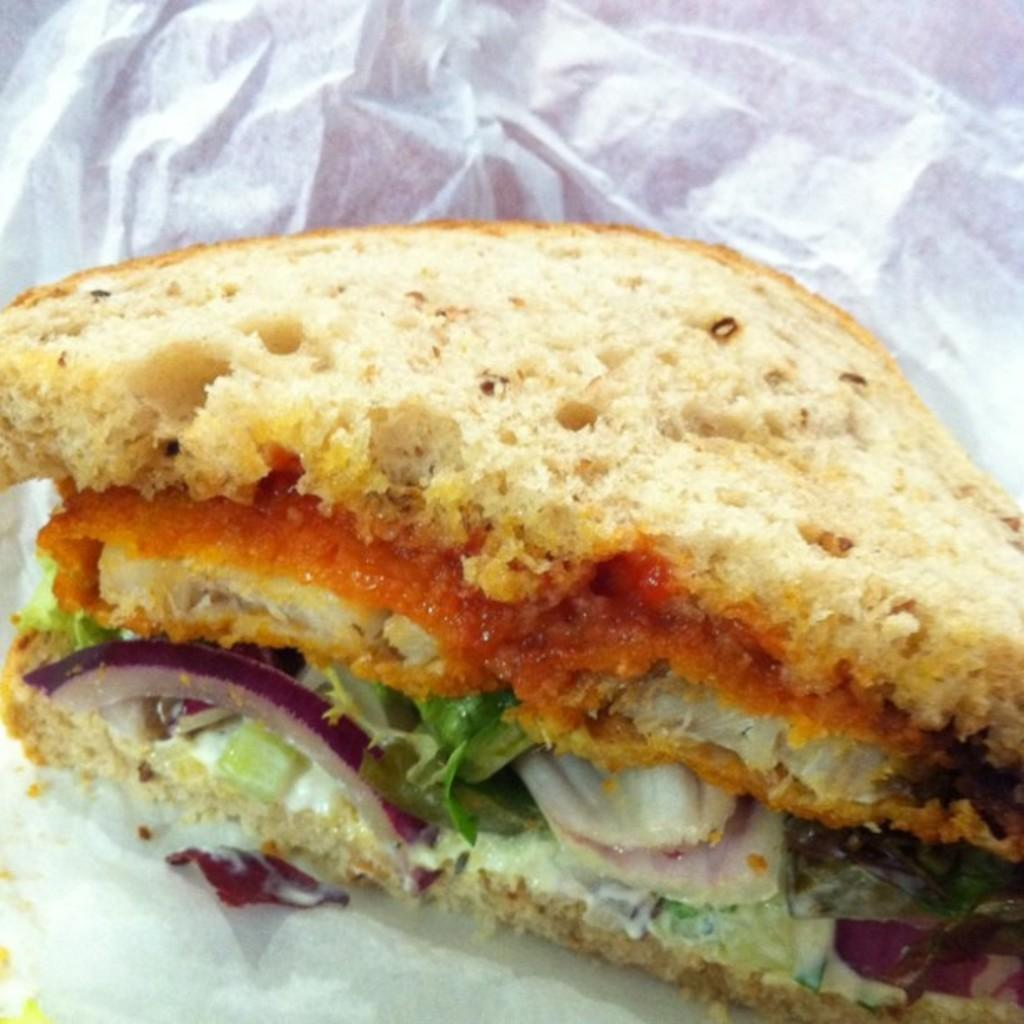What is the main subject of the image? There is a food item in the image. How is the food item presented in the image? The food item is wrapped in paper. Where is the playground located in the image? There is no playground present in the image. What type of nail is being used to hold the food item in place? There is no nail present in the image, and the food item is wrapped in paper, not held in place by any fasteners. 